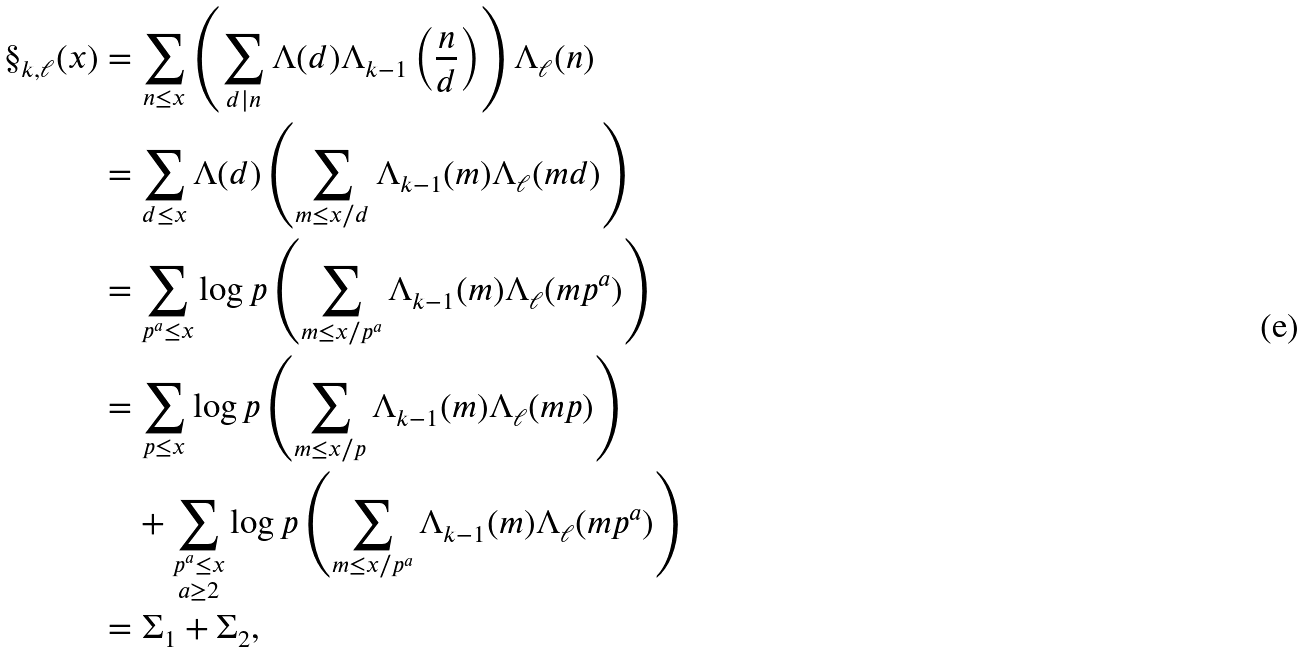<formula> <loc_0><loc_0><loc_500><loc_500>\S _ { k , \ell } ( x ) & = \sum _ { n \leq x } \left ( \sum _ { d | n } \Lambda ( d ) \Lambda _ { k - 1 } \left ( \frac { n } { d } \right ) \right ) \Lambda _ { \ell } ( n ) \\ & = \sum _ { d \leq x } \Lambda ( d ) \left ( \sum _ { m \leq x / d } \Lambda _ { k - 1 } ( m ) \Lambda _ { \ell } ( m d ) \right ) \\ & = \sum _ { p ^ { a } \leq x } \log p \left ( \sum _ { m \leq x / p ^ { a } } \Lambda _ { k - 1 } ( m ) \Lambda _ { \ell } ( m p ^ { a } ) \right ) \\ & = \sum _ { p \leq x } \log p \left ( \sum _ { m \leq x / p } \Lambda _ { k - 1 } ( m ) \Lambda _ { \ell } ( m p ) \right ) \\ & \quad + \sum _ { \substack { p ^ { a } \leq x \\ a \geq 2 } } \log p \left ( \sum _ { m \leq x / p ^ { a } } \Lambda _ { k - 1 } ( m ) \Lambda _ { \ell } ( m p ^ { a } ) \right ) \\ & = \Sigma _ { 1 } + \Sigma _ { 2 } ,</formula> 